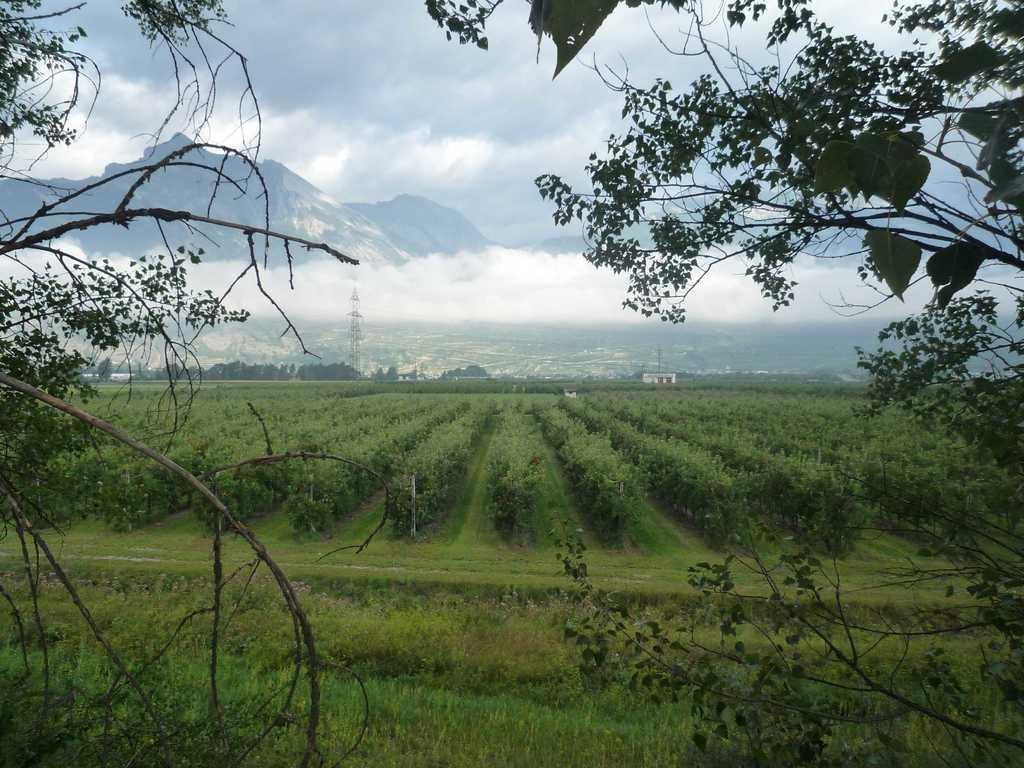What type of vegetation can be seen in the image? There are plants and trees in the image. What is the ground surface like in the image? The ground with grass is visible in the image. What type of geographical feature can be seen in the distance? There are mountains in the image. What structure is present in the image? There is a tower in the image. What part of the natural environment is visible in the image? The sky is visible in the image. What can be observed in the sky? Clouds are present in the sky. Where are the scissors located in the image? There are no scissors present in the image. What type of yoke is being used by the clouds in the image? There is no yoke present in the image, as clouds are natural phenomena and do not require any equipment or tools. 